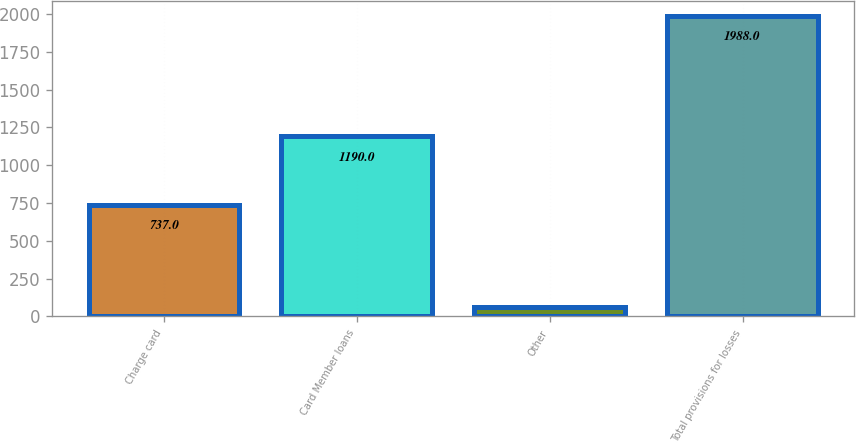<chart> <loc_0><loc_0><loc_500><loc_500><bar_chart><fcel>Charge card<fcel>Card Member loans<fcel>Other<fcel>Total provisions for losses<nl><fcel>737<fcel>1190<fcel>61<fcel>1988<nl></chart> 